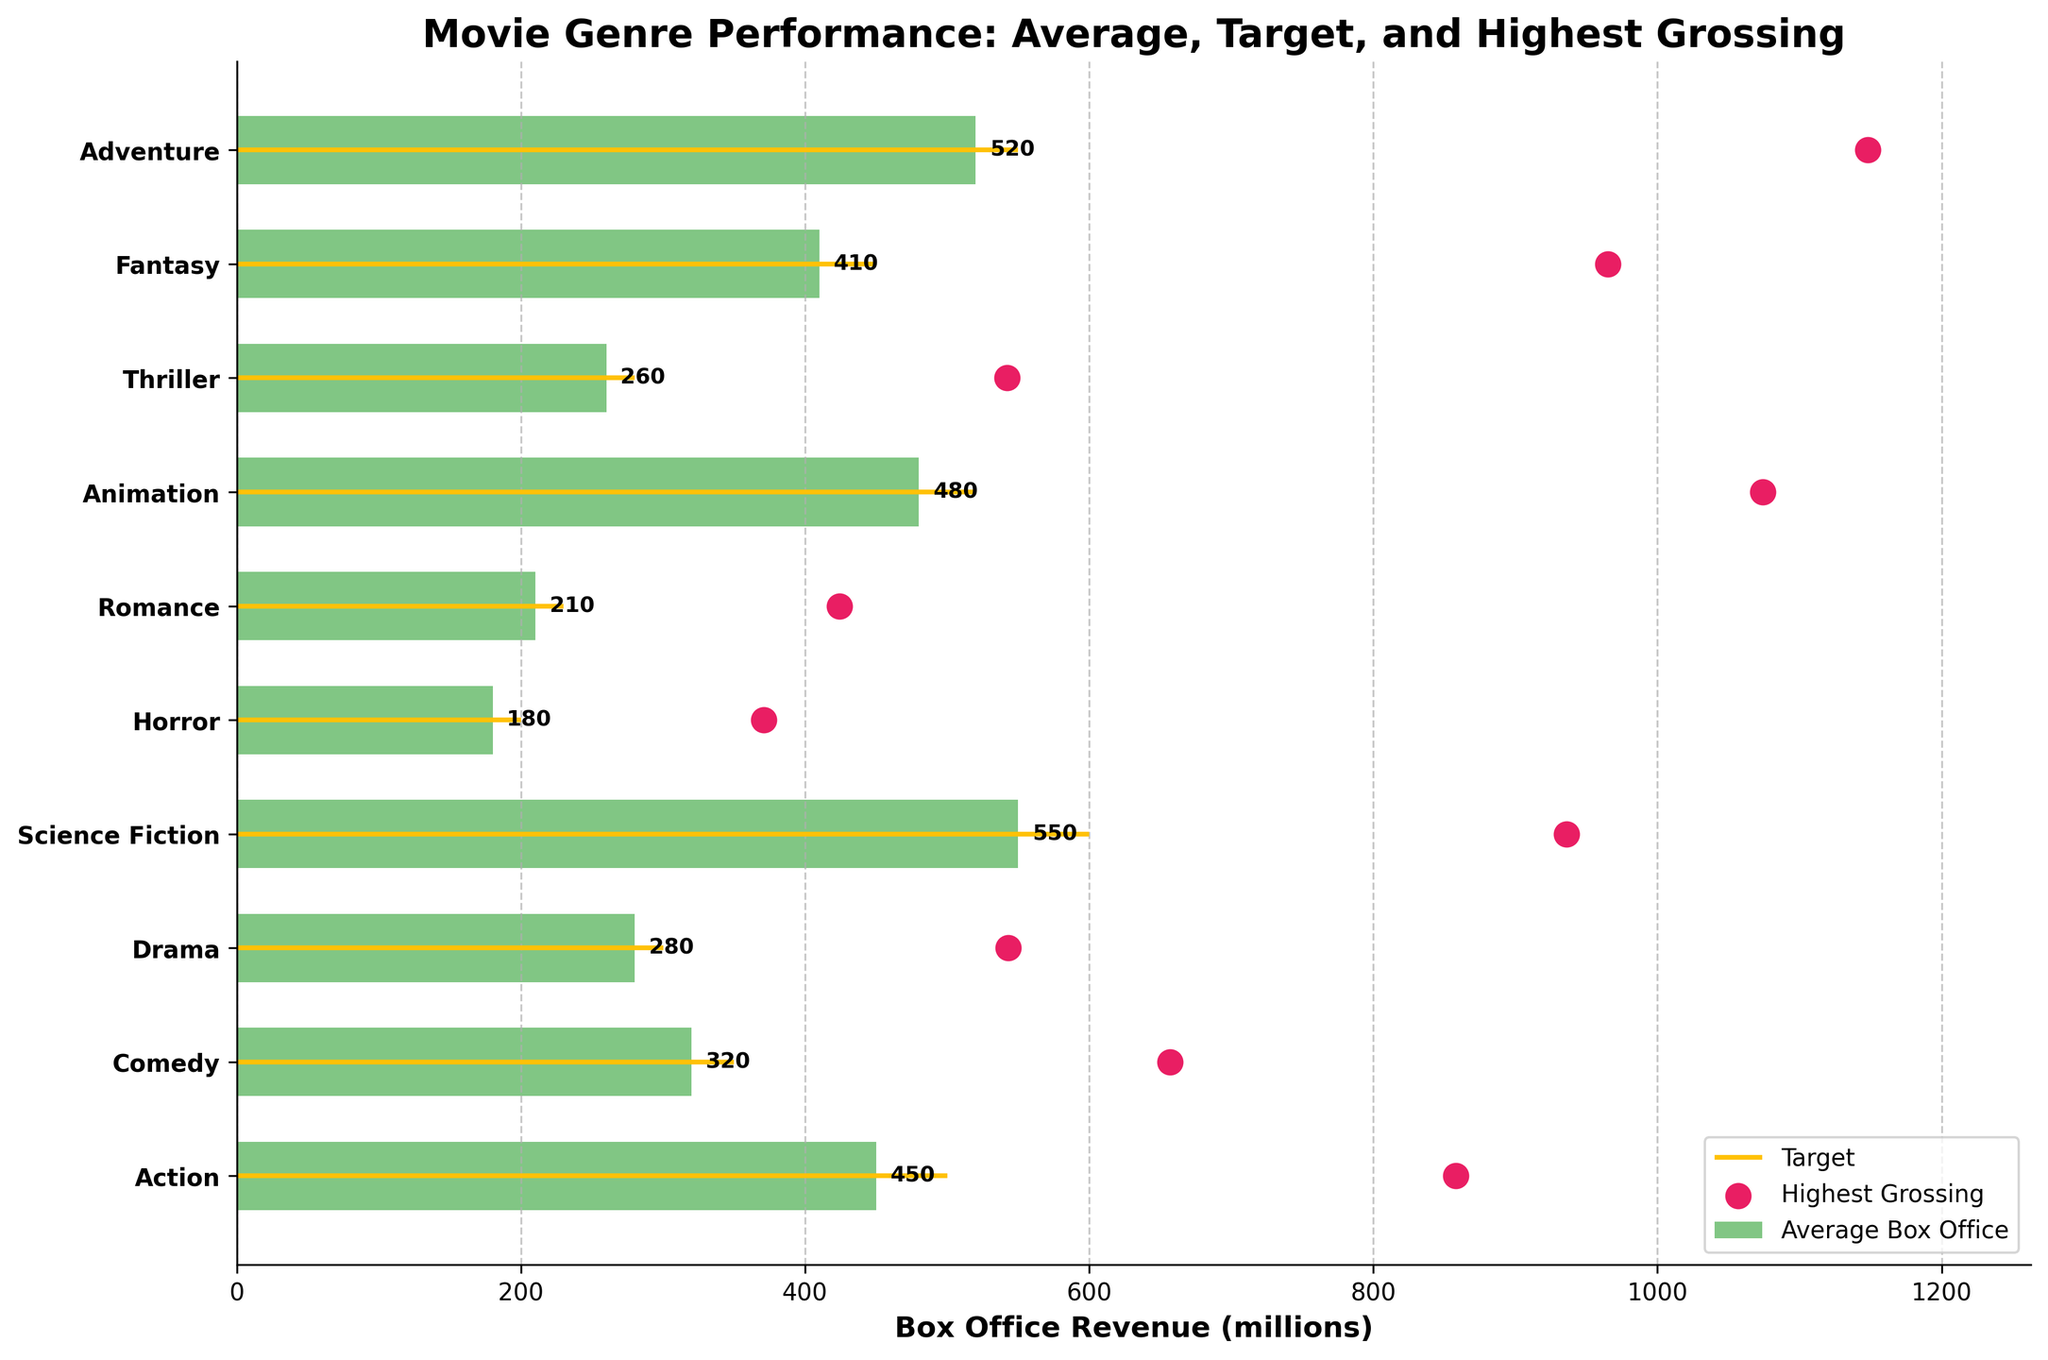What's the title of the chart? The title of the chart is displayed at the top and reads "Movie Genre Performance: Average, Target, and Highest Grossing".
Answer: Movie Genre Performance: Average, Target, and Highest Grossing What genre has the highest average box office revenue? By looking at the bar lengths, Science Fiction has the longest bar for average box office revenue.
Answer: Science Fiction How far is the average box office revenue for Action from its target? Action's average box office revenue is 450 million, and its target is 500 million. The difference is 500 - 450 = 50 million.
Answer: 50 million Which genre exceeds its target box office revenue by the largest margin? Comparing the difference between average and target across all genres, Science Fiction exceeds its target by 550 - 600 = -50 million, Animation by 480 - 520 = -40 million, Adventure by 520 - 550 = -30 million. Science Fiction falls short by the largest margin.
Answer: Science Fiction falls short What is the highest grossing revenue across all genres, and which genre achieved it? The highest grossing marker reaches the furthest right. Adventure has the highest marker at 1148 million.
Answer: Adventure Are there any genres where the average box office revenue meets or exceeds the target? By comparing the average bar lengths with the target lines, no genre has an average box office revenue that meets or exceeds its target.
Answer: No Which genre has the lowest average box office revenue, and what is this value? The shortest bar belongs to Horror with an average box office revenue of 180 million.
Answer: Horror, 180 million How much higher is the highest grossing revenue of Animation compared to its average box office revenue? Animation's highest grossing is 1074 million, and its average is 480 million. The difference is 1074 - 480 = 594 million.
Answer: 594 million What is the comparison between the highest grossing revenues of Comedy and Drama? Comedy's highest grossing revenue is 657 million, and Drama's is 543 million. Comedy's highest grossing is greater.
Answer: Comedy > Drama Which genre is closest to its target in terms of average box office revenue, and what is the difference? Comparing the differences between average and target values for all genres, Romance (target 230 million, average 210 million) has a difference of 20 million, which is the smallest gap.
Answer: Romance, 20 million 